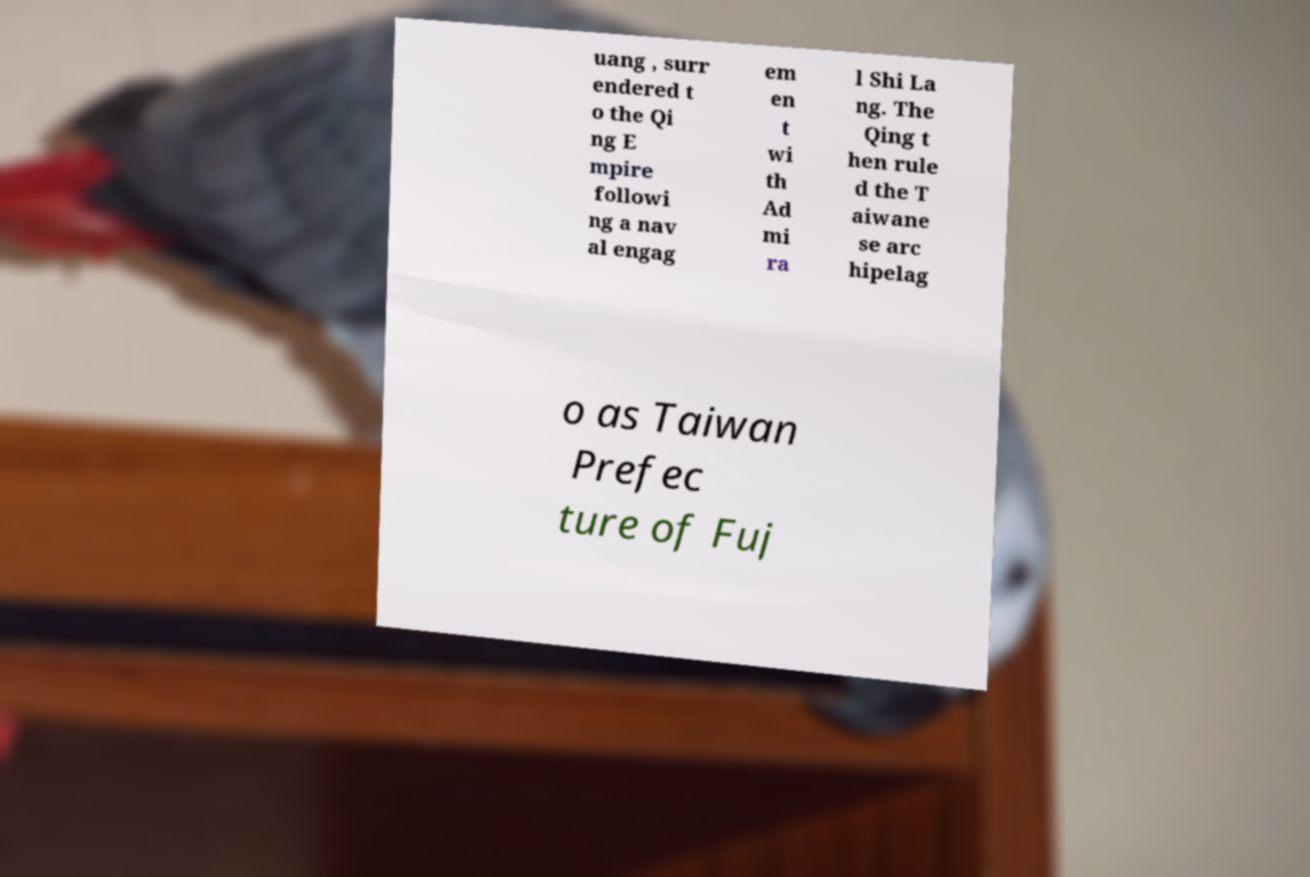Could you assist in decoding the text presented in this image and type it out clearly? uang , surr endered t o the Qi ng E mpire followi ng a nav al engag em en t wi th Ad mi ra l Shi La ng. The Qing t hen rule d the T aiwane se arc hipelag o as Taiwan Prefec ture of Fuj 